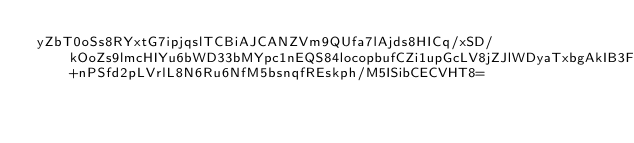Convert code to text. <code><loc_0><loc_0><loc_500><loc_500><_SML_>yZbT0oSs8RYxtG7ipjqslTCBiAJCANZVm9QUfa7lAjds8HICq/xSD/kOoZs9lmcHIYu6bWD33bMYpc1nEQS84locopbufCZi1upGcLV8jZJlWDyaTxbgAkIB3FZWaW3MHfJDhVIwCzlzFc0VCetMeMnD9gr0ZfD+nPSfd2pLVrlL8N6Ru6NfM5bsnqfREskph/M5ISibCECVHT8=</code> 